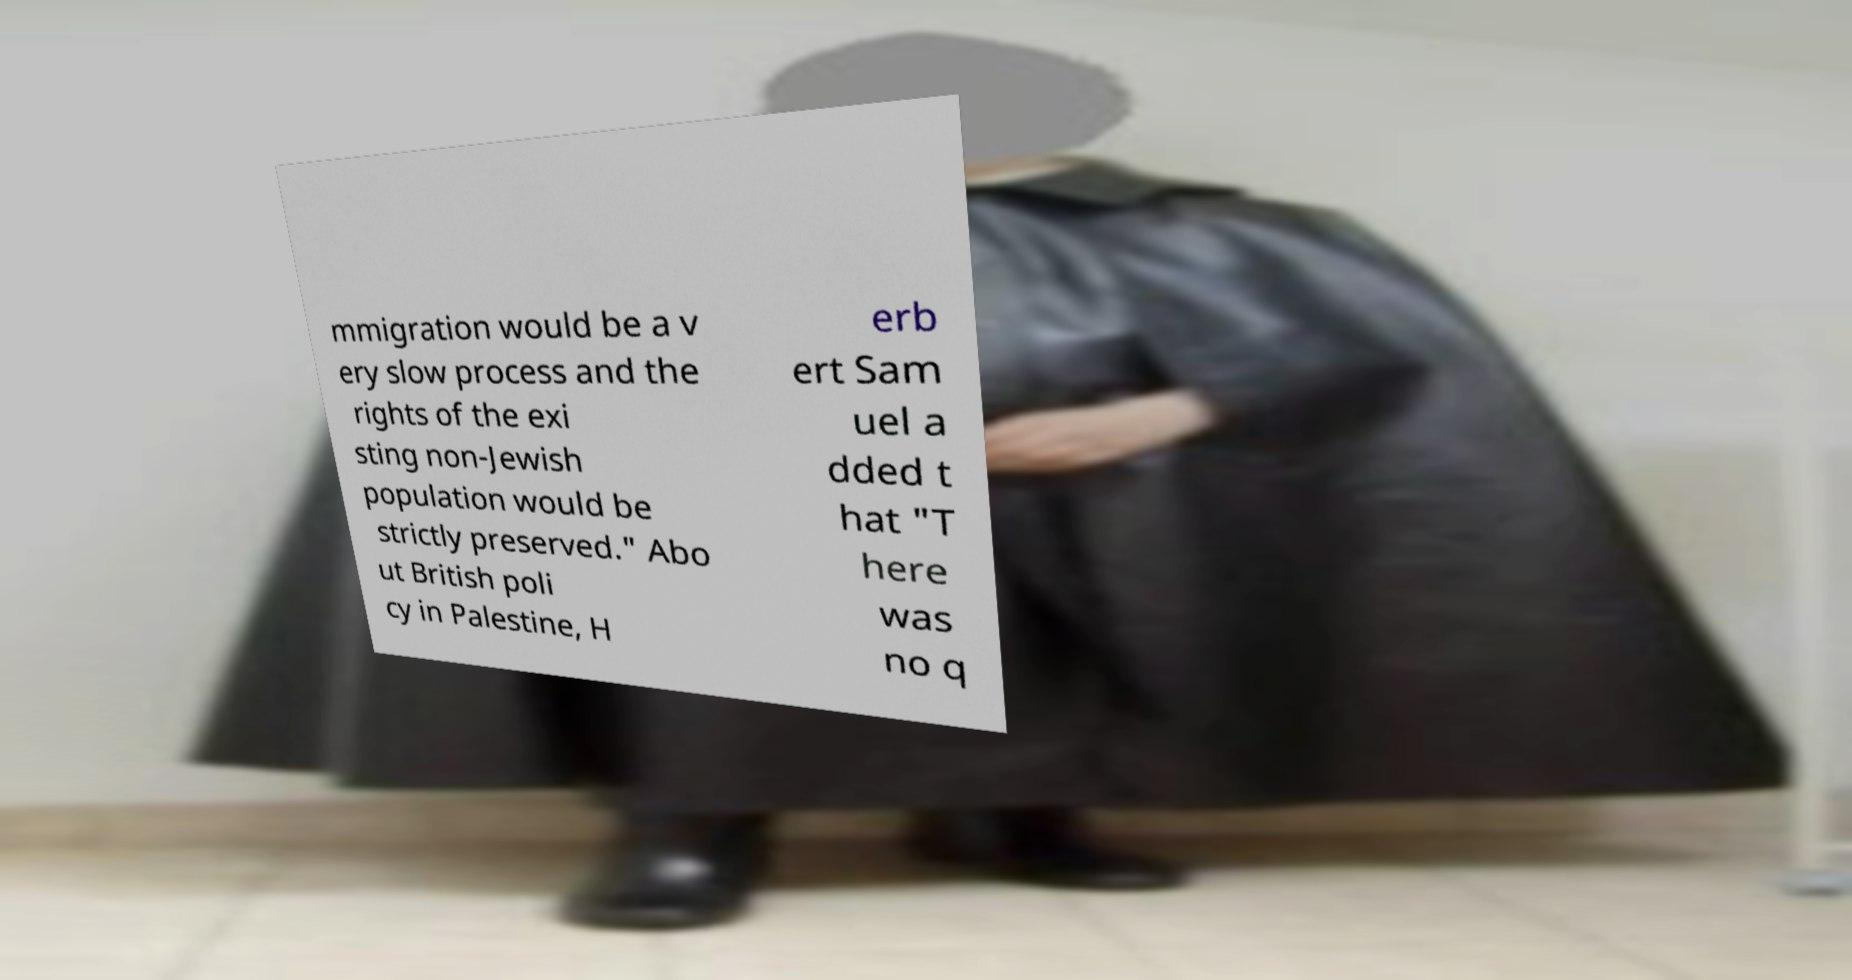Can you accurately transcribe the text from the provided image for me? mmigration would be a v ery slow process and the rights of the exi sting non-Jewish population would be strictly preserved." Abo ut British poli cy in Palestine, H erb ert Sam uel a dded t hat "T here was no q 